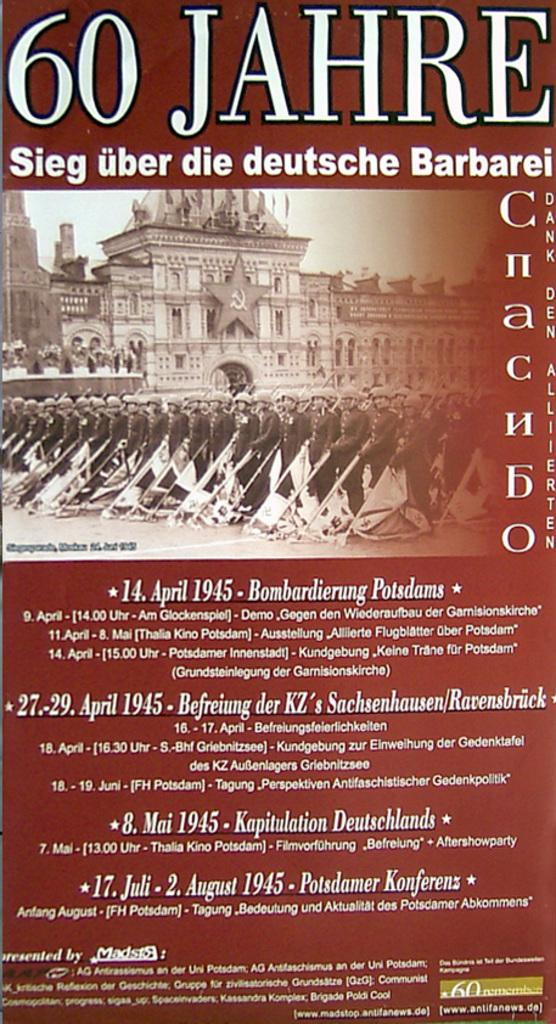What is featured in the image? There is a poster in the image. What is depicted on the poster? The poster contains groups of people standing. What can be seen behind the people in the poster? There is a building visible behind the people in the poster. What is visible in the background of the poster? The sky is visible in the background of the poster. What type of mitten is being used to rub the poster in the image? There is no mitten or rubbing action present in the image; it features a poster with people standing and a building in the background. 